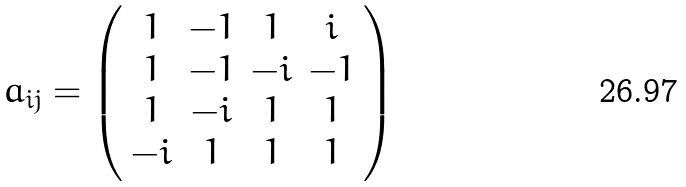<formula> <loc_0><loc_0><loc_500><loc_500>a _ { i j } = \left ( \begin{array} { c c c c } 1 & - 1 & 1 & i \\ 1 & - 1 & - i & - 1 \\ 1 & - i & 1 & 1 \\ - i & 1 & 1 & 1 \end{array} \right )</formula> 